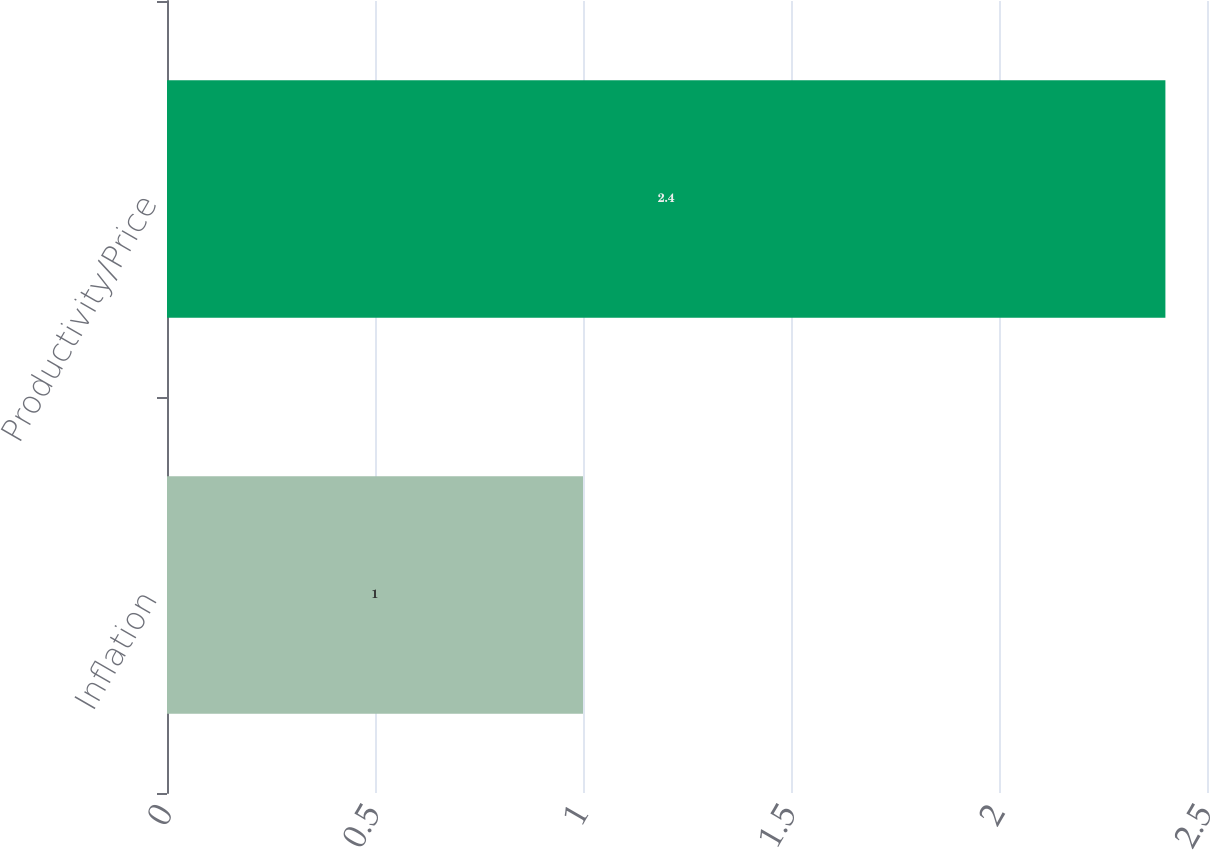<chart> <loc_0><loc_0><loc_500><loc_500><bar_chart><fcel>Inflation<fcel>Productivity/Price<nl><fcel>1<fcel>2.4<nl></chart> 